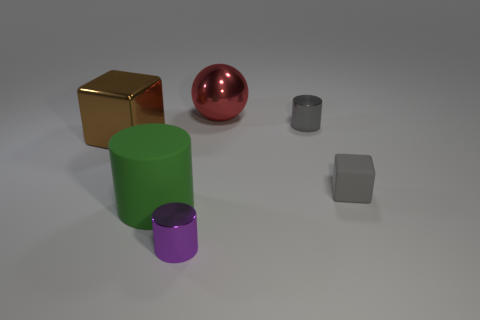Add 1 red metallic cylinders. How many objects exist? 7 Subtract all cubes. How many objects are left? 4 Add 5 gray rubber blocks. How many gray rubber blocks are left? 6 Add 5 small gray things. How many small gray things exist? 7 Subtract 1 green cylinders. How many objects are left? 5 Subtract all brown metallic objects. Subtract all brown metallic things. How many objects are left? 4 